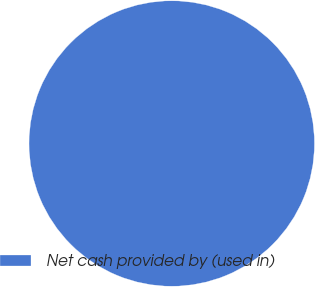<chart> <loc_0><loc_0><loc_500><loc_500><pie_chart><fcel>Net cash provided by (used in)<nl><fcel>100.0%<nl></chart> 